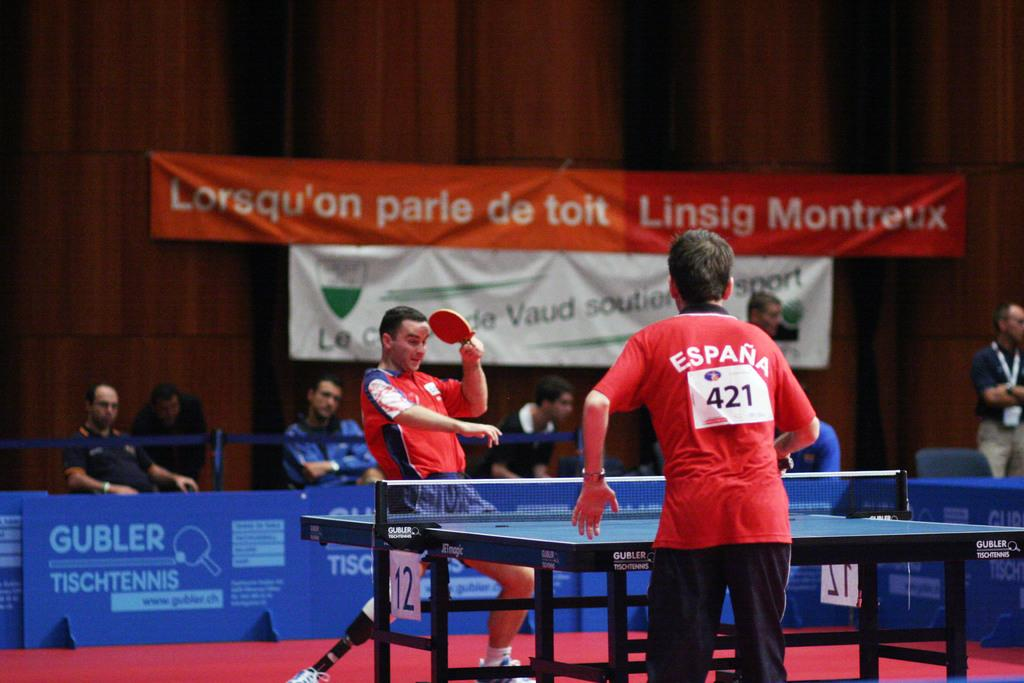<image>
Describe the image concisely. a player with the number 421 on their back 